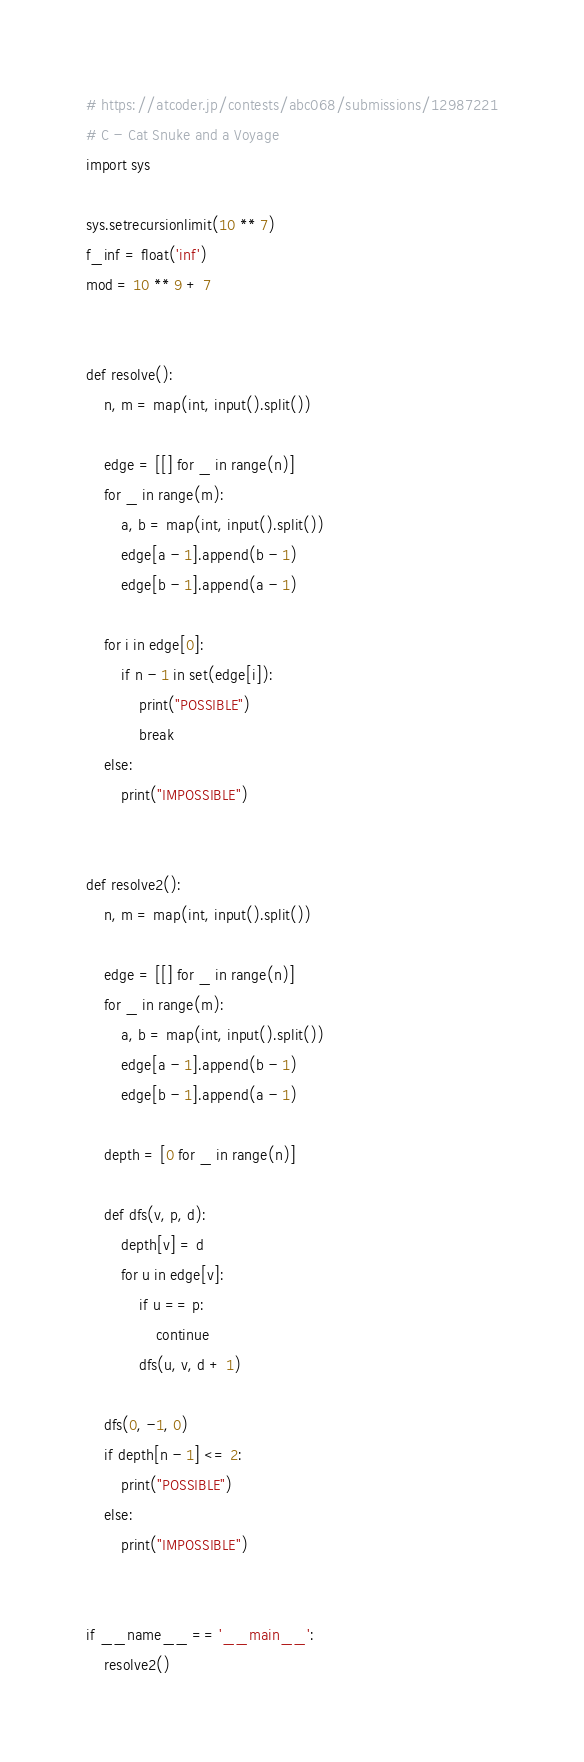Convert code to text. <code><loc_0><loc_0><loc_500><loc_500><_Python_># https://atcoder.jp/contests/abc068/submissions/12987221
# C - Cat Snuke and a Voyage
import sys

sys.setrecursionlimit(10 ** 7)
f_inf = float('inf')
mod = 10 ** 9 + 7


def resolve():
    n, m = map(int, input().split())

    edge = [[] for _ in range(n)]
    for _ in range(m):
        a, b = map(int, input().split())
        edge[a - 1].append(b - 1)
        edge[b - 1].append(a - 1)

    for i in edge[0]:
        if n - 1 in set(edge[i]):
            print("POSSIBLE")
            break
    else:
        print("IMPOSSIBLE")


def resolve2():
    n, m = map(int, input().split())

    edge = [[] for _ in range(n)]
    for _ in range(m):
        a, b = map(int, input().split())
        edge[a - 1].append(b - 1)
        edge[b - 1].append(a - 1)

    depth = [0 for _ in range(n)]

    def dfs(v, p, d):
        depth[v] = d
        for u in edge[v]:
            if u == p:
                continue
            dfs(u, v, d + 1)

    dfs(0, -1, 0)
    if depth[n - 1] <= 2:
        print("POSSIBLE")
    else:
        print("IMPOSSIBLE")


if __name__ == '__main__':
    resolve2()
</code> 